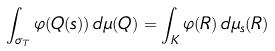Convert formula to latex. <formula><loc_0><loc_0><loc_500><loc_500>\int _ { \sigma _ { T } } \varphi ( Q ( s ) ) \, d \mu ( Q ) = \int _ { K } \varphi ( R ) \, d \mu _ { s } ( R )</formula> 